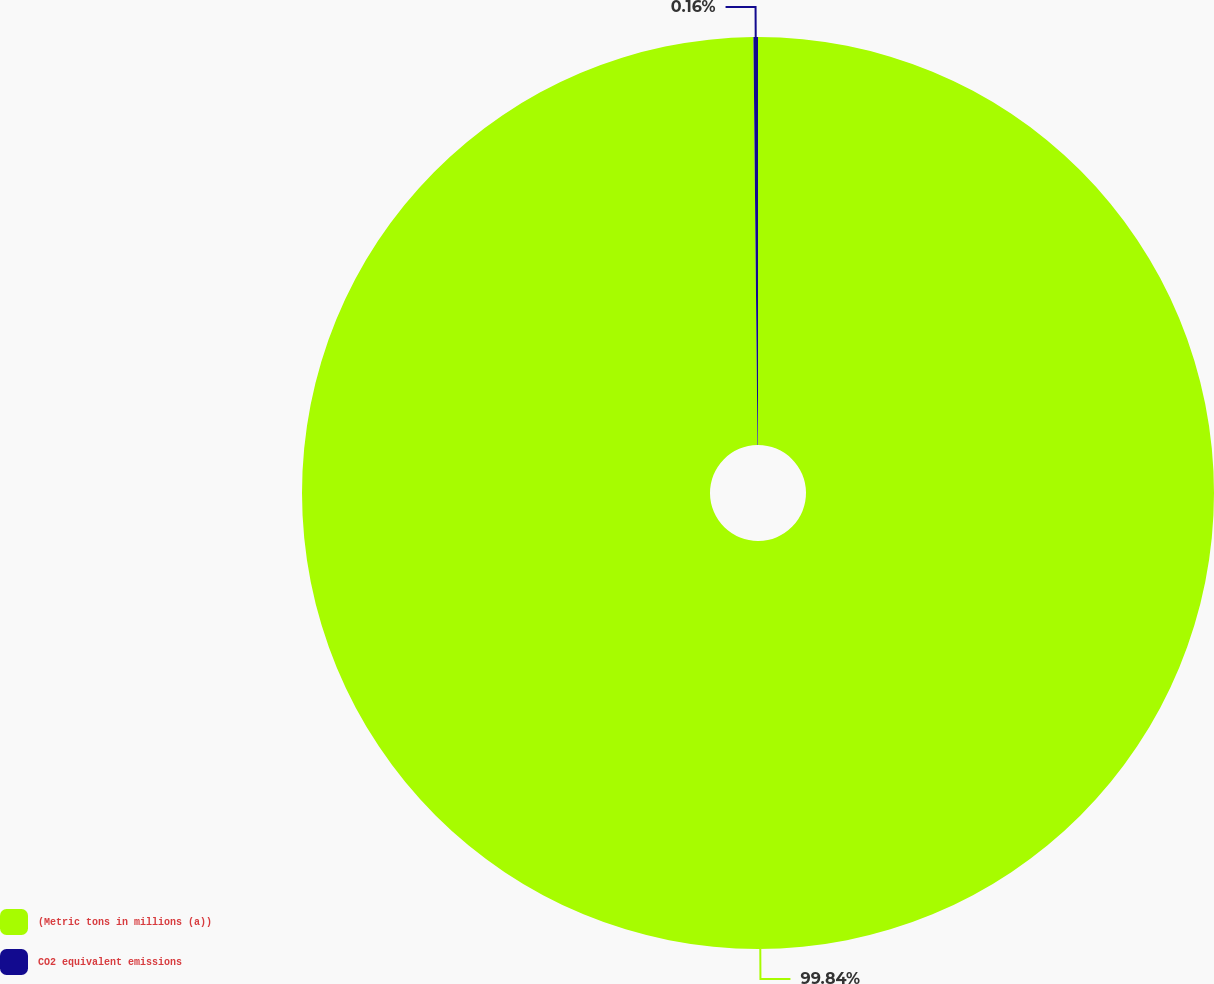<chart> <loc_0><loc_0><loc_500><loc_500><pie_chart><fcel>(Metric tons in millions (a))<fcel>CO2 equivalent emissions<nl><fcel>99.84%<fcel>0.16%<nl></chart> 